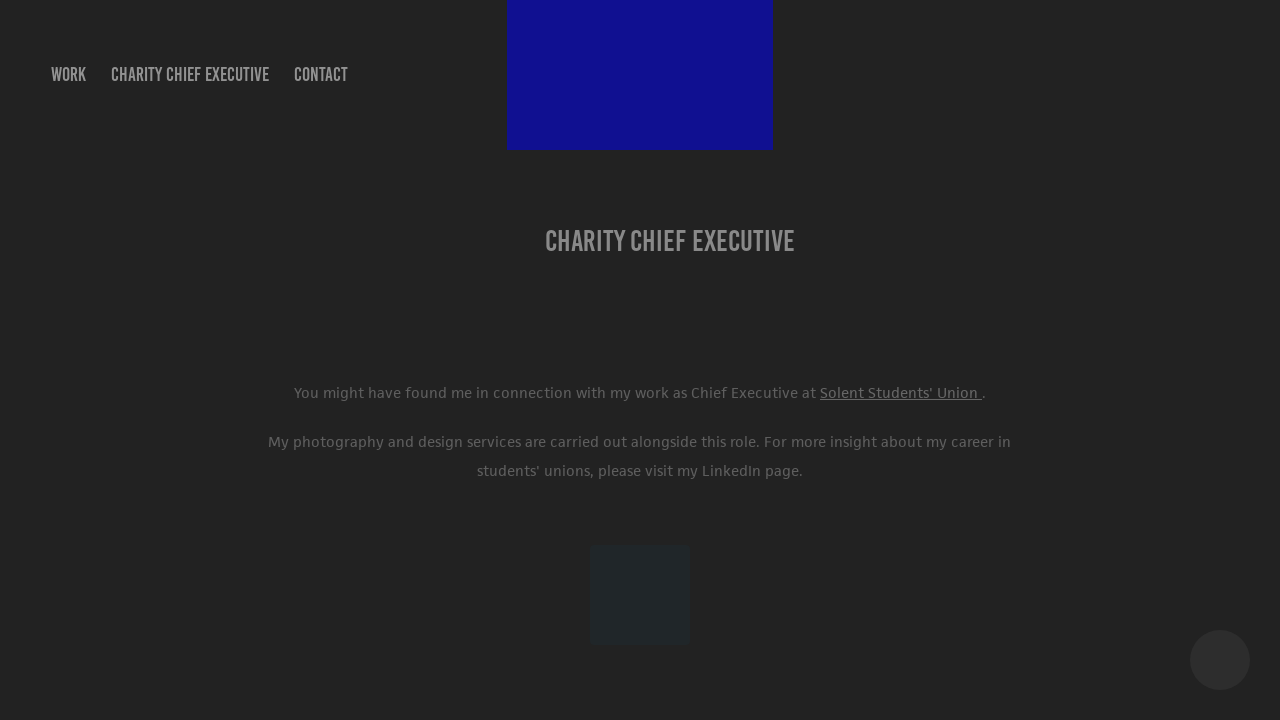How can I start building this website with HTML from the ground up? To start building a website with HTML from the ground up, you'll want to begin by creating a basic HTML file. Start with the <!DOCTYPE html> declaration, then create the <html>, <head>, and <body> elements. Inside the <body>, you can add content like headings (<h1>), paragraphs (<p>), links (<a>), and images (<img>). Use CSS for styling and make your layout responsive. Consider learning about CSS frameworks like Bootstrap to help manage your styles and layout more efficiently. There are also many resources online, such as tutorials and documentation, to guide you as you learn. 